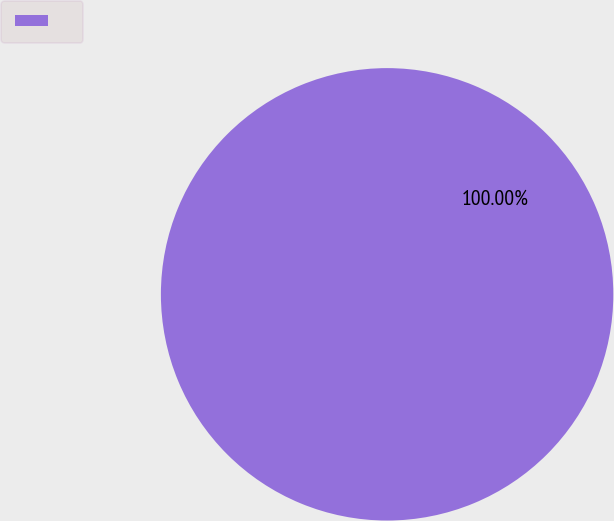<chart> <loc_0><loc_0><loc_500><loc_500><pie_chart><ecel><nl><fcel>100.0%<nl></chart> 